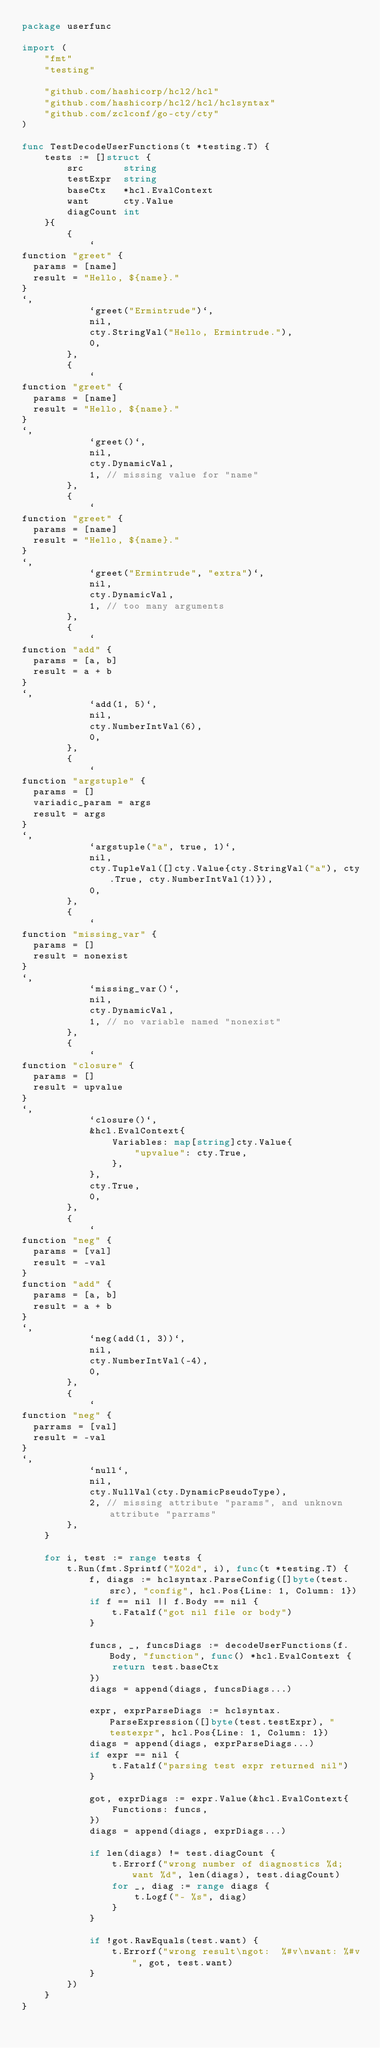Convert code to text. <code><loc_0><loc_0><loc_500><loc_500><_Go_>package userfunc

import (
	"fmt"
	"testing"

	"github.com/hashicorp/hcl2/hcl"
	"github.com/hashicorp/hcl2/hcl/hclsyntax"
	"github.com/zclconf/go-cty/cty"
)

func TestDecodeUserFunctions(t *testing.T) {
	tests := []struct {
		src       string
		testExpr  string
		baseCtx   *hcl.EvalContext
		want      cty.Value
		diagCount int
	}{
		{
			`
function "greet" {
  params = [name]
  result = "Hello, ${name}."
}
`,
			`greet("Ermintrude")`,
			nil,
			cty.StringVal("Hello, Ermintrude."),
			0,
		},
		{
			`
function "greet" {
  params = [name]
  result = "Hello, ${name}."
}
`,
			`greet()`,
			nil,
			cty.DynamicVal,
			1, // missing value for "name"
		},
		{
			`
function "greet" {
  params = [name]
  result = "Hello, ${name}."
}
`,
			`greet("Ermintrude", "extra")`,
			nil,
			cty.DynamicVal,
			1, // too many arguments
		},
		{
			`
function "add" {
  params = [a, b]
  result = a + b
}
`,
			`add(1, 5)`,
			nil,
			cty.NumberIntVal(6),
			0,
		},
		{
			`
function "argstuple" {
  params = []
  variadic_param = args
  result = args
}
`,
			`argstuple("a", true, 1)`,
			nil,
			cty.TupleVal([]cty.Value{cty.StringVal("a"), cty.True, cty.NumberIntVal(1)}),
			0,
		},
		{
			`
function "missing_var" {
  params = []
  result = nonexist
}
`,
			`missing_var()`,
			nil,
			cty.DynamicVal,
			1, // no variable named "nonexist"
		},
		{
			`
function "closure" {
  params = []
  result = upvalue
}
`,
			`closure()`,
			&hcl.EvalContext{
				Variables: map[string]cty.Value{
					"upvalue": cty.True,
				},
			},
			cty.True,
			0,
		},
		{
			`
function "neg" {
  params = [val]
  result = -val
}
function "add" {
  params = [a, b]
  result = a + b
}
`,
			`neg(add(1, 3))`,
			nil,
			cty.NumberIntVal(-4),
			0,
		},
		{
			`
function "neg" {
  parrams = [val]
  result = -val
}
`,
			`null`,
			nil,
			cty.NullVal(cty.DynamicPseudoType),
			2, // missing attribute "params", and unknown attribute "parrams"
		},
	}

	for i, test := range tests {
		t.Run(fmt.Sprintf("%02d", i), func(t *testing.T) {
			f, diags := hclsyntax.ParseConfig([]byte(test.src), "config", hcl.Pos{Line: 1, Column: 1})
			if f == nil || f.Body == nil {
				t.Fatalf("got nil file or body")
			}

			funcs, _, funcsDiags := decodeUserFunctions(f.Body, "function", func() *hcl.EvalContext {
				return test.baseCtx
			})
			diags = append(diags, funcsDiags...)

			expr, exprParseDiags := hclsyntax.ParseExpression([]byte(test.testExpr), "testexpr", hcl.Pos{Line: 1, Column: 1})
			diags = append(diags, exprParseDiags...)
			if expr == nil {
				t.Fatalf("parsing test expr returned nil")
			}

			got, exprDiags := expr.Value(&hcl.EvalContext{
				Functions: funcs,
			})
			diags = append(diags, exprDiags...)

			if len(diags) != test.diagCount {
				t.Errorf("wrong number of diagnostics %d; want %d", len(diags), test.diagCount)
				for _, diag := range diags {
					t.Logf("- %s", diag)
				}
			}

			if !got.RawEquals(test.want) {
				t.Errorf("wrong result\ngot:  %#v\nwant: %#v", got, test.want)
			}
		})
	}
}
</code> 